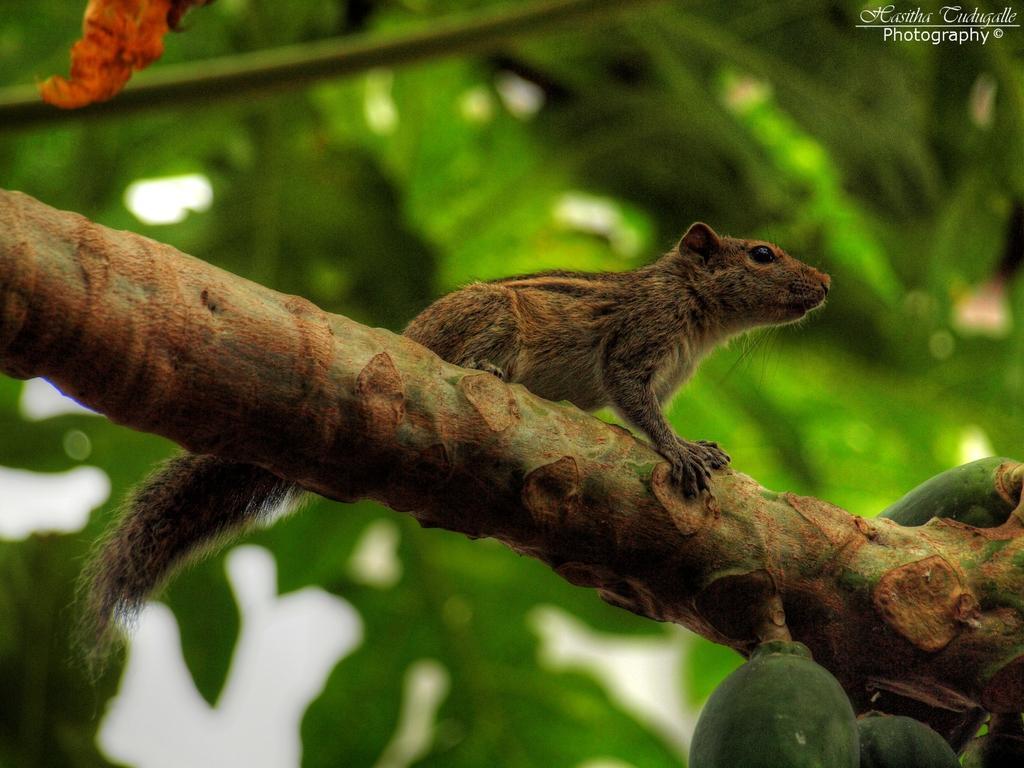Please provide a concise description of this image. In the middle of this image there is a squirrel on a stem. On the right side there are fruits to this stem. In the background the leaves are visible. 